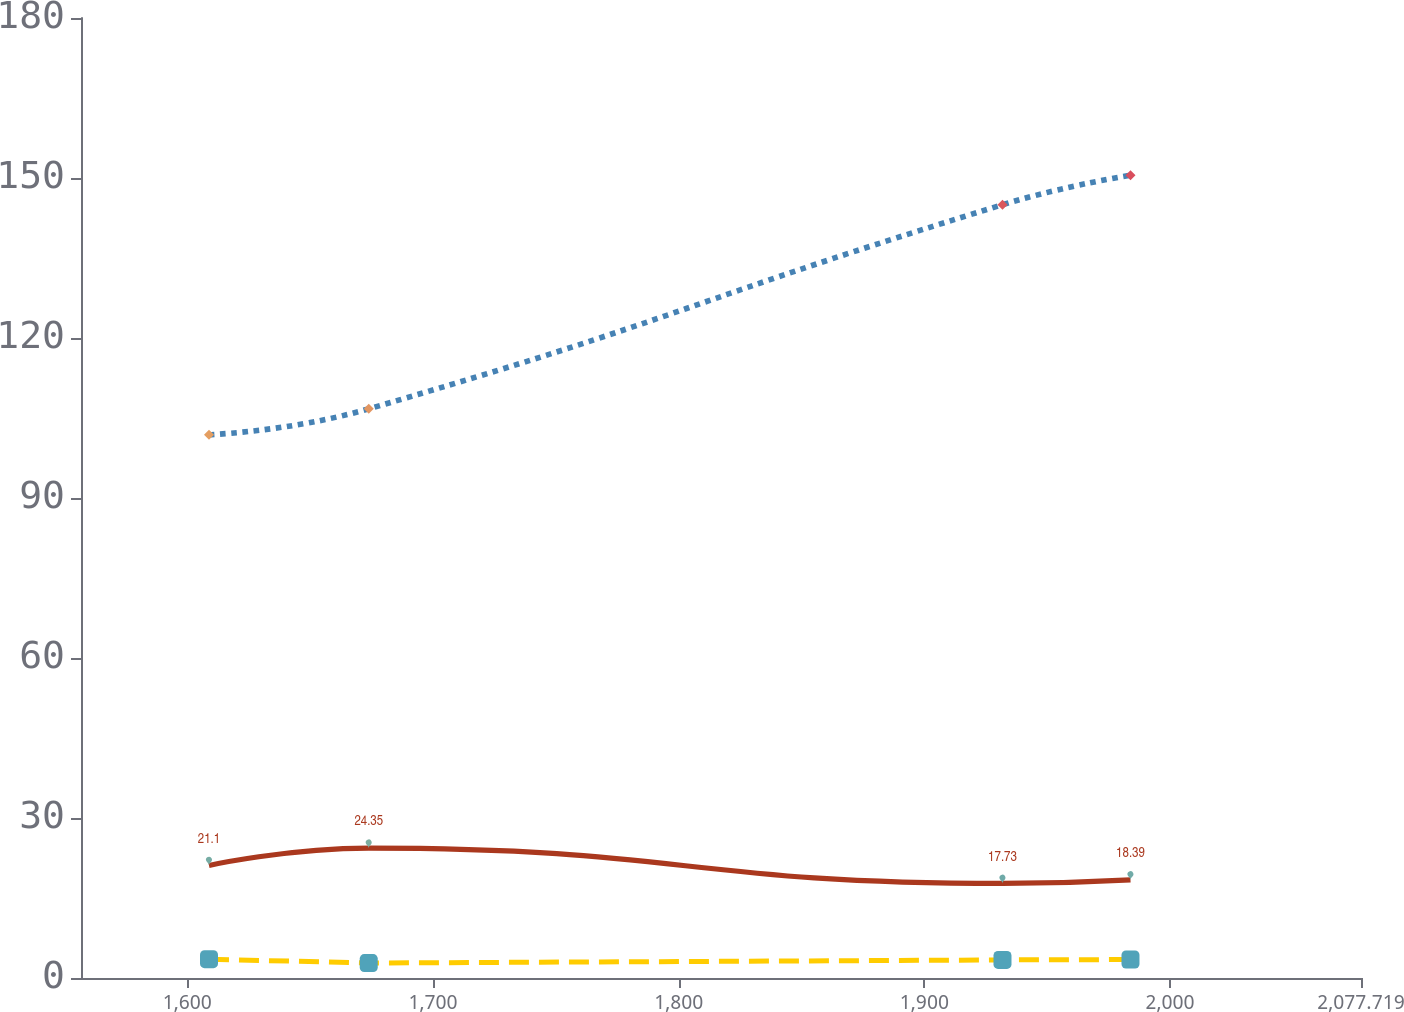<chart> <loc_0><loc_0><loc_500><loc_500><line_chart><ecel><fcel>Postretirement Benefit Plans<fcel>Prescription Drug Subsidy<fcel>Pension Plans<nl><fcel>1608.81<fcel>101.86<fcel>21.1<fcel>3.53<nl><fcel>1673.83<fcel>106.72<fcel>24.35<fcel>2.8<nl><fcel>1931.79<fcel>144.99<fcel>17.73<fcel>3.39<nl><fcel>1983.89<fcel>150.51<fcel>18.39<fcel>3.46<nl><fcel>2129.82<fcel>139.04<fcel>21.76<fcel>2.87<nl></chart> 